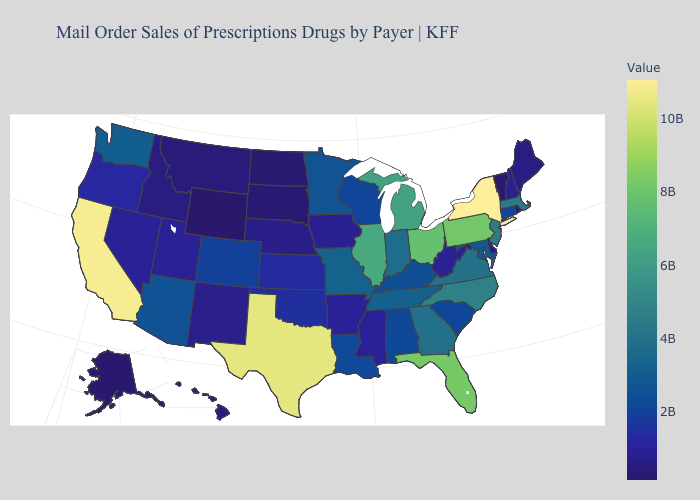Does Florida have the lowest value in the South?
Write a very short answer. No. Does Georgia have the highest value in the USA?
Write a very short answer. No. Does New York have the highest value in the USA?
Give a very brief answer. Yes. 